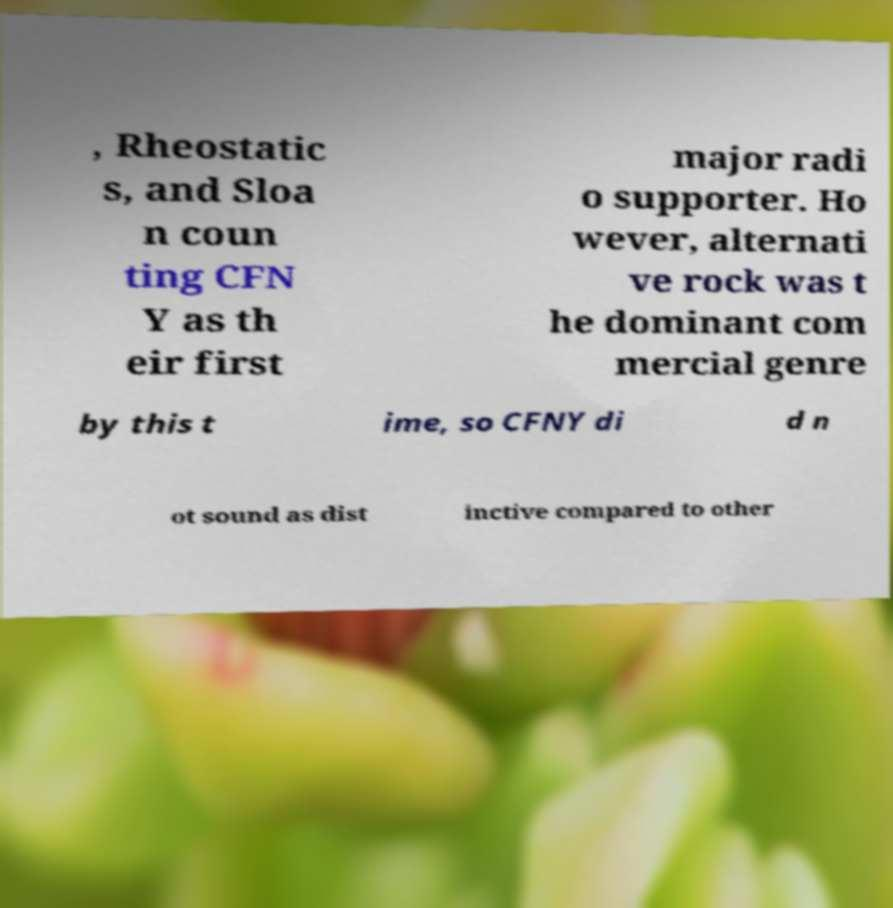Could you extract and type out the text from this image? , Rheostatic s, and Sloa n coun ting CFN Y as th eir first major radi o supporter. Ho wever, alternati ve rock was t he dominant com mercial genre by this t ime, so CFNY di d n ot sound as dist inctive compared to other 